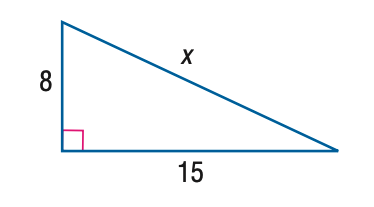Question: Find x.
Choices:
A. 8
B. 12.7
C. 15
D. 17
Answer with the letter. Answer: D 